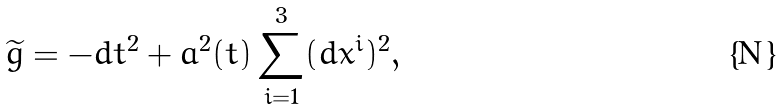Convert formula to latex. <formula><loc_0><loc_0><loc_500><loc_500>\widetilde { g } = - d t ^ { 2 } + a ^ { 2 } ( t ) \sum _ { i = 1 } ^ { 3 } ( d x ^ { i } ) ^ { 2 } ,</formula> 